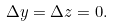<formula> <loc_0><loc_0><loc_500><loc_500>\Delta y = \Delta z = 0 .</formula> 